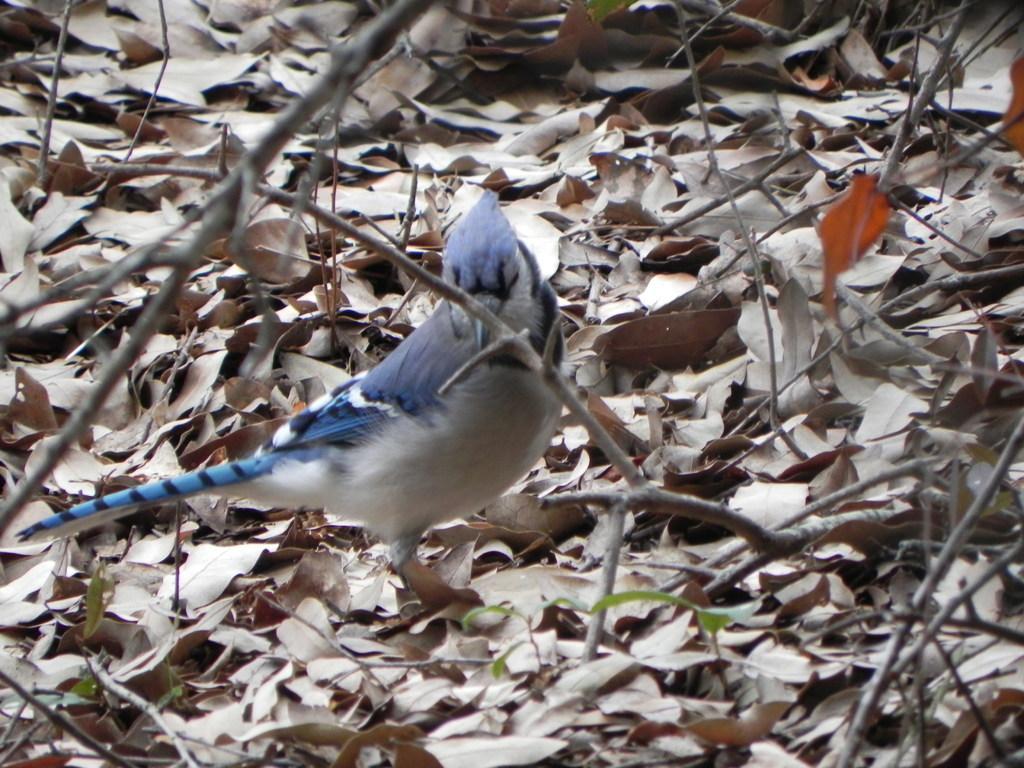Describe this image in one or two sentences. In this image we can see a bird and there are some dry leaves and stems on the ground. 